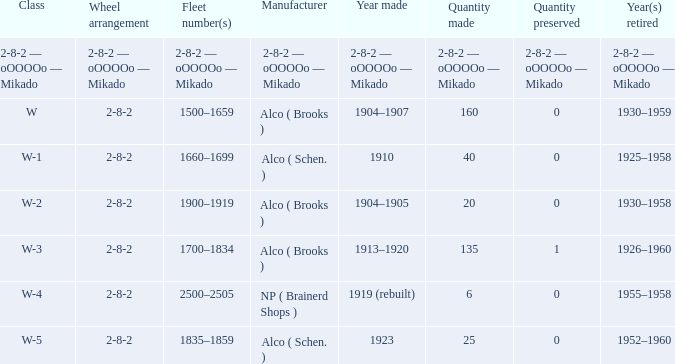What type of locomotive has a 2-8-2 wheel arrangement and 25 examples manufactured? W-5. 